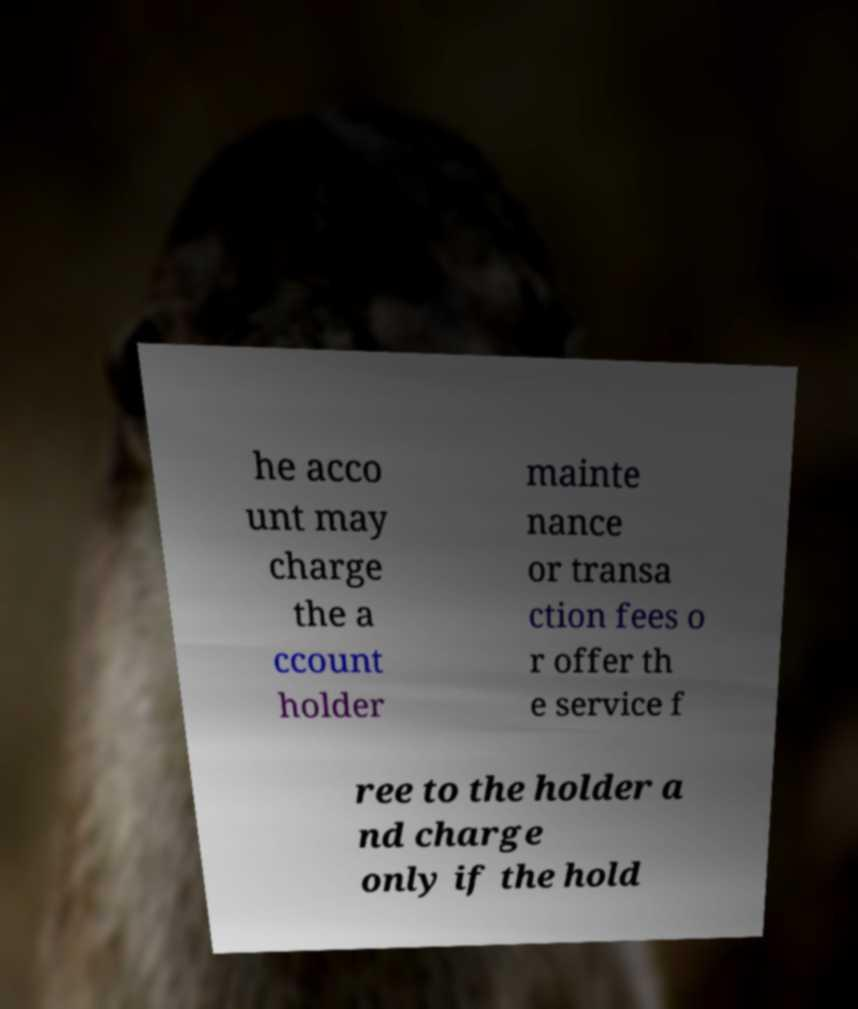Please identify and transcribe the text found in this image. he acco unt may charge the a ccount holder mainte nance or transa ction fees o r offer th e service f ree to the holder a nd charge only if the hold 